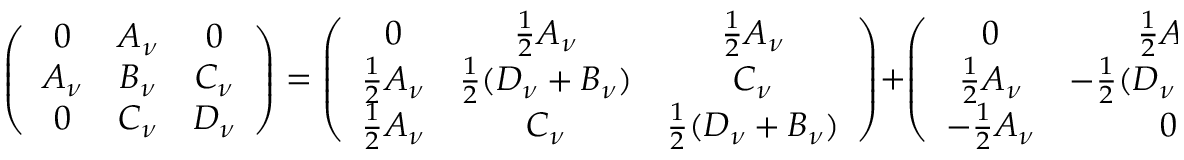<formula> <loc_0><loc_0><loc_500><loc_500>\left ( \begin{array} { c c c } { 0 } & { { A _ { \nu } } } & { 0 } \\ { { A _ { \nu } } } & { { B _ { \nu } } } & { { C _ { \nu } } } \\ { 0 } & { { C _ { \nu } } } & { { D _ { \nu } } } \end{array} \right ) = \left ( \begin{array} { c c c } { 0 } & { { \frac { 1 } { 2 } A _ { \nu } } } & { { \frac { 1 } { 2 } A _ { \nu } } } \\ { { \frac { 1 } { 2 } A _ { \nu } } } & { { \frac { 1 } { 2 } ( D _ { \nu } + B _ { \nu } ) } } & { { C _ { \nu } } } \\ { { \frac { 1 } { 2 } A _ { \nu } } } & { { C _ { \nu } } } & { { \frac { 1 } { 2 } ( D _ { \nu } + B _ { \nu } ) } } \end{array} \right ) + \left ( \begin{array} { c c c } { 0 } & { { \frac { 1 } { 2 } A _ { \nu } } } & { { - \frac { 1 } { 2 } A _ { \nu } } } \\ { { \frac { 1 } { 2 } A _ { \nu } } } & { { - \frac { 1 } { 2 } ( D _ { \nu } - B _ { \nu } ) } } & { 0 } \\ { { - \frac { 1 } { 2 } A _ { \nu } } } & { 0 } & { { \frac { 1 } { 2 } ( D _ { \nu } - B _ { \nu } ) } } \end{array} \right ) .</formula> 